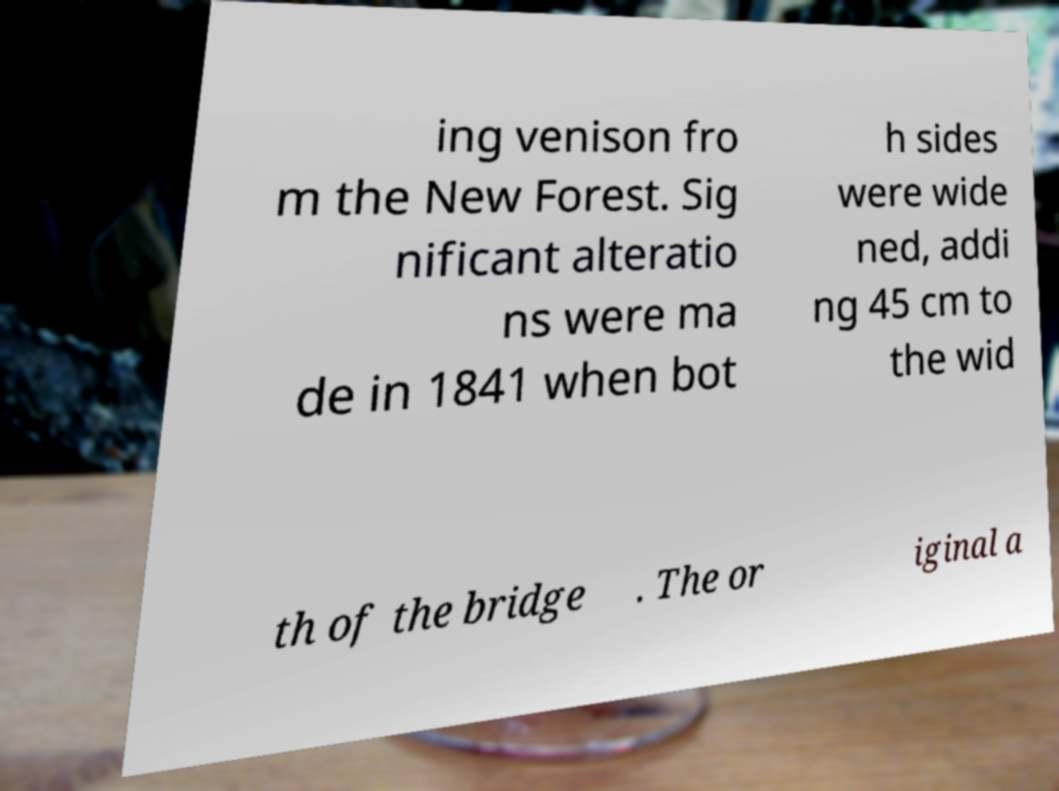For documentation purposes, I need the text within this image transcribed. Could you provide that? ing venison fro m the New Forest. Sig nificant alteratio ns were ma de in 1841 when bot h sides were wide ned, addi ng 45 cm to the wid th of the bridge . The or iginal a 